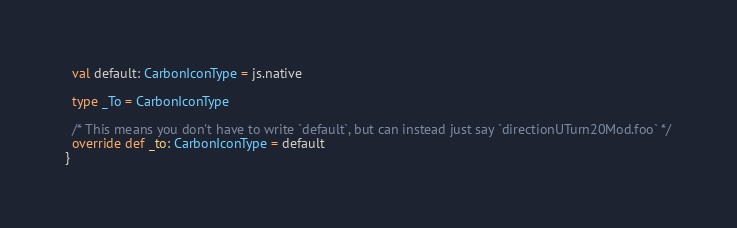Convert code to text. <code><loc_0><loc_0><loc_500><loc_500><_Scala_>  val default: CarbonIconType = js.native
  
  type _To = CarbonIconType
  
  /* This means you don't have to write `default`, but can instead just say `directionUTurn20Mod.foo` */
  override def _to: CarbonIconType = default
}
</code> 